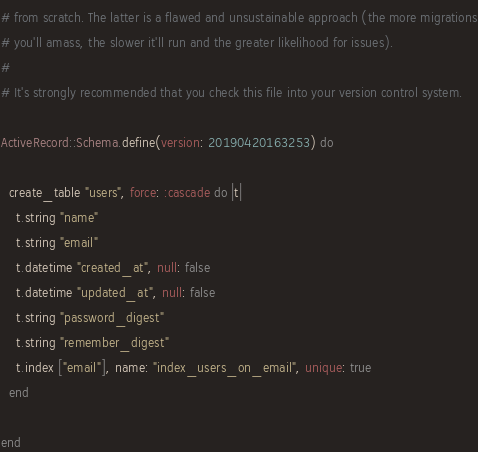<code> <loc_0><loc_0><loc_500><loc_500><_Ruby_># from scratch. The latter is a flawed and unsustainable approach (the more migrations
# you'll amass, the slower it'll run and the greater likelihood for issues).
#
# It's strongly recommended that you check this file into your version control system.

ActiveRecord::Schema.define(version: 20190420163253) do

  create_table "users", force: :cascade do |t|
    t.string "name"
    t.string "email"
    t.datetime "created_at", null: false
    t.datetime "updated_at", null: false
    t.string "password_digest"
    t.string "remember_digest"
    t.index ["email"], name: "index_users_on_email", unique: true
  end

end
</code> 